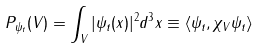<formula> <loc_0><loc_0><loc_500><loc_500>P _ { \psi _ { t } } ( V ) = \int _ { V } | \psi _ { t } ( { x } ) | ^ { 2 } d ^ { 3 } x \equiv \langle \psi _ { t } , \chi _ { V } \psi _ { t } \rangle</formula> 